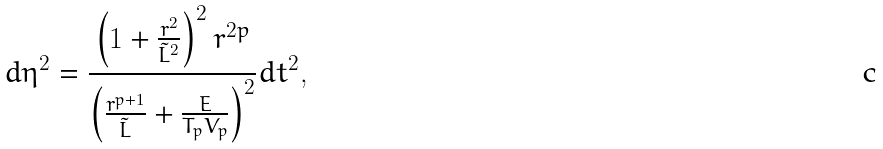<formula> <loc_0><loc_0><loc_500><loc_500>d \eta ^ { 2 } = { \frac { \left ( 1 + { \frac { r ^ { 2 } } { \tilde { L } ^ { 2 } } } \right ) ^ { 2 } r ^ { 2 p } } { \left ( { \frac { r ^ { p + 1 } } { \tilde { L } } } + { \frac { E } { T _ { p } V _ { p } } } \right ) ^ { 2 } } } d t ^ { 2 } ,</formula> 